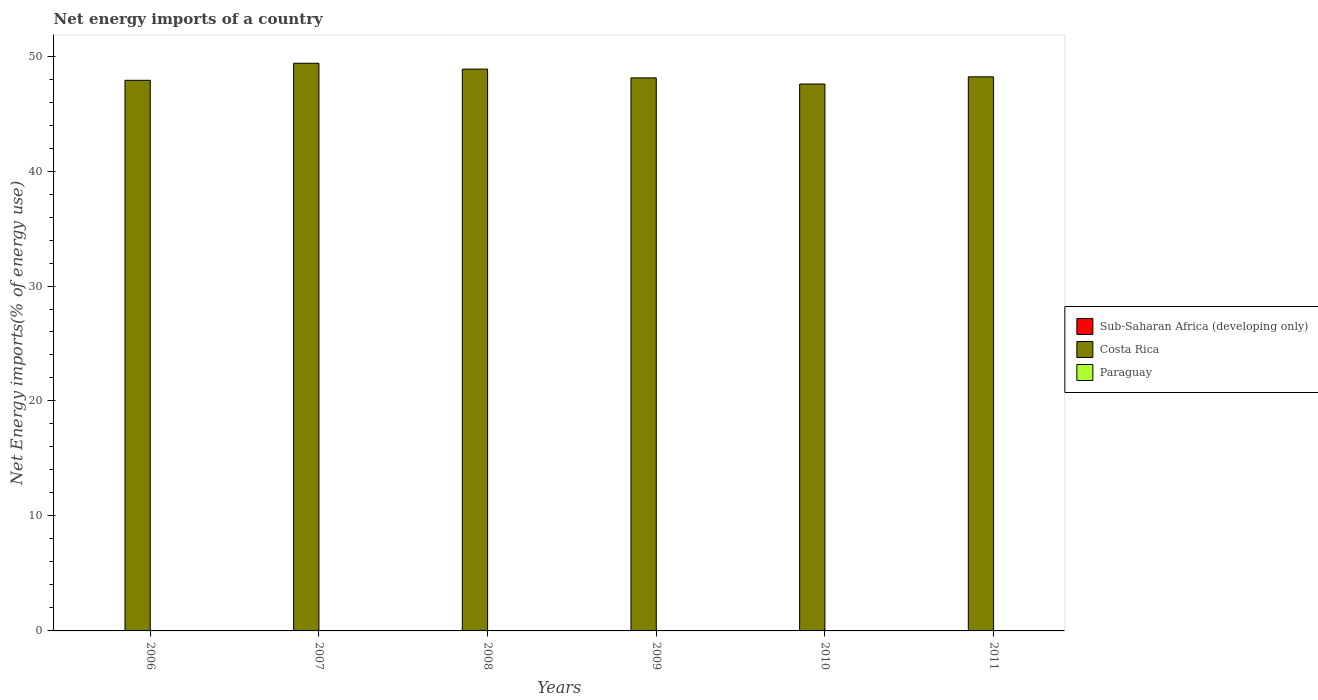How many different coloured bars are there?
Ensure brevity in your answer.  1. How many bars are there on the 1st tick from the left?
Your answer should be very brief. 1. In how many cases, is the number of bars for a given year not equal to the number of legend labels?
Provide a succinct answer. 6. What is the net energy imports in Costa Rica in 2010?
Offer a terse response. 47.57. Across all years, what is the maximum net energy imports in Costa Rica?
Your response must be concise. 49.37. Across all years, what is the minimum net energy imports in Sub-Saharan Africa (developing only)?
Offer a very short reply. 0. What is the total net energy imports in Costa Rica in the graph?
Ensure brevity in your answer.  290. What is the difference between the net energy imports in Costa Rica in 2007 and that in 2010?
Make the answer very short. 1.81. What is the difference between the net energy imports in Sub-Saharan Africa (developing only) in 2008 and the net energy imports in Costa Rica in 2010?
Provide a succinct answer. -47.57. What is the average net energy imports in Costa Rica per year?
Give a very brief answer. 48.33. What is the ratio of the net energy imports in Costa Rica in 2006 to that in 2008?
Your answer should be very brief. 0.98. What is the difference between the highest and the second highest net energy imports in Costa Rica?
Offer a very short reply. 0.51. What is the difference between the highest and the lowest net energy imports in Costa Rica?
Your response must be concise. 1.81. Is it the case that in every year, the sum of the net energy imports in Costa Rica and net energy imports in Sub-Saharan Africa (developing only) is greater than the net energy imports in Paraguay?
Provide a short and direct response. Yes. How many years are there in the graph?
Provide a short and direct response. 6. Does the graph contain any zero values?
Your response must be concise. Yes. How many legend labels are there?
Give a very brief answer. 3. How are the legend labels stacked?
Give a very brief answer. Vertical. What is the title of the graph?
Your answer should be very brief. Net energy imports of a country. Does "North America" appear as one of the legend labels in the graph?
Offer a very short reply. No. What is the label or title of the X-axis?
Your response must be concise. Years. What is the label or title of the Y-axis?
Ensure brevity in your answer.  Net Energy imports(% of energy use). What is the Net Energy imports(% of energy use) in Sub-Saharan Africa (developing only) in 2006?
Offer a very short reply. 0. What is the Net Energy imports(% of energy use) in Costa Rica in 2006?
Offer a very short reply. 47.89. What is the Net Energy imports(% of energy use) in Paraguay in 2006?
Provide a succinct answer. 0. What is the Net Energy imports(% of energy use) of Sub-Saharan Africa (developing only) in 2007?
Your answer should be compact. 0. What is the Net Energy imports(% of energy use) in Costa Rica in 2007?
Give a very brief answer. 49.37. What is the Net Energy imports(% of energy use) in Costa Rica in 2008?
Ensure brevity in your answer.  48.87. What is the Net Energy imports(% of energy use) of Paraguay in 2008?
Ensure brevity in your answer.  0. What is the Net Energy imports(% of energy use) of Sub-Saharan Africa (developing only) in 2009?
Offer a very short reply. 0. What is the Net Energy imports(% of energy use) in Costa Rica in 2009?
Your answer should be compact. 48.1. What is the Net Energy imports(% of energy use) of Paraguay in 2009?
Offer a terse response. 0. What is the Net Energy imports(% of energy use) of Sub-Saharan Africa (developing only) in 2010?
Offer a terse response. 0. What is the Net Energy imports(% of energy use) of Costa Rica in 2010?
Your answer should be very brief. 47.57. What is the Net Energy imports(% of energy use) in Paraguay in 2010?
Ensure brevity in your answer.  0. What is the Net Energy imports(% of energy use) of Costa Rica in 2011?
Provide a short and direct response. 48.2. What is the Net Energy imports(% of energy use) in Paraguay in 2011?
Provide a succinct answer. 0. Across all years, what is the maximum Net Energy imports(% of energy use) in Costa Rica?
Offer a terse response. 49.37. Across all years, what is the minimum Net Energy imports(% of energy use) in Costa Rica?
Give a very brief answer. 47.57. What is the total Net Energy imports(% of energy use) in Sub-Saharan Africa (developing only) in the graph?
Make the answer very short. 0. What is the total Net Energy imports(% of energy use) in Costa Rica in the graph?
Give a very brief answer. 290. What is the difference between the Net Energy imports(% of energy use) of Costa Rica in 2006 and that in 2007?
Your answer should be compact. -1.48. What is the difference between the Net Energy imports(% of energy use) in Costa Rica in 2006 and that in 2008?
Your response must be concise. -0.97. What is the difference between the Net Energy imports(% of energy use) of Costa Rica in 2006 and that in 2009?
Offer a very short reply. -0.21. What is the difference between the Net Energy imports(% of energy use) in Costa Rica in 2006 and that in 2010?
Provide a short and direct response. 0.32. What is the difference between the Net Energy imports(% of energy use) of Costa Rica in 2006 and that in 2011?
Offer a very short reply. -0.3. What is the difference between the Net Energy imports(% of energy use) of Costa Rica in 2007 and that in 2008?
Your answer should be very brief. 0.51. What is the difference between the Net Energy imports(% of energy use) in Costa Rica in 2007 and that in 2009?
Offer a very short reply. 1.27. What is the difference between the Net Energy imports(% of energy use) in Costa Rica in 2007 and that in 2010?
Your answer should be very brief. 1.81. What is the difference between the Net Energy imports(% of energy use) in Costa Rica in 2007 and that in 2011?
Provide a succinct answer. 1.18. What is the difference between the Net Energy imports(% of energy use) of Costa Rica in 2008 and that in 2009?
Make the answer very short. 0.76. What is the difference between the Net Energy imports(% of energy use) of Costa Rica in 2008 and that in 2010?
Offer a terse response. 1.3. What is the difference between the Net Energy imports(% of energy use) of Costa Rica in 2008 and that in 2011?
Offer a terse response. 0.67. What is the difference between the Net Energy imports(% of energy use) in Costa Rica in 2009 and that in 2010?
Your answer should be compact. 0.53. What is the difference between the Net Energy imports(% of energy use) in Costa Rica in 2009 and that in 2011?
Offer a very short reply. -0.09. What is the difference between the Net Energy imports(% of energy use) in Costa Rica in 2010 and that in 2011?
Your response must be concise. -0.63. What is the average Net Energy imports(% of energy use) of Costa Rica per year?
Make the answer very short. 48.33. What is the average Net Energy imports(% of energy use) of Paraguay per year?
Your answer should be compact. 0. What is the ratio of the Net Energy imports(% of energy use) of Costa Rica in 2006 to that in 2007?
Give a very brief answer. 0.97. What is the ratio of the Net Energy imports(% of energy use) in Costa Rica in 2006 to that in 2008?
Your answer should be compact. 0.98. What is the ratio of the Net Energy imports(% of energy use) in Costa Rica in 2006 to that in 2009?
Keep it short and to the point. 1. What is the ratio of the Net Energy imports(% of energy use) of Costa Rica in 2006 to that in 2010?
Your response must be concise. 1.01. What is the ratio of the Net Energy imports(% of energy use) in Costa Rica in 2007 to that in 2008?
Provide a short and direct response. 1.01. What is the ratio of the Net Energy imports(% of energy use) in Costa Rica in 2007 to that in 2009?
Provide a succinct answer. 1.03. What is the ratio of the Net Energy imports(% of energy use) of Costa Rica in 2007 to that in 2010?
Offer a very short reply. 1.04. What is the ratio of the Net Energy imports(% of energy use) of Costa Rica in 2007 to that in 2011?
Your answer should be very brief. 1.02. What is the ratio of the Net Energy imports(% of energy use) in Costa Rica in 2008 to that in 2009?
Provide a short and direct response. 1.02. What is the ratio of the Net Energy imports(% of energy use) in Costa Rica in 2008 to that in 2010?
Your response must be concise. 1.03. What is the ratio of the Net Energy imports(% of energy use) of Costa Rica in 2008 to that in 2011?
Ensure brevity in your answer.  1.01. What is the ratio of the Net Energy imports(% of energy use) of Costa Rica in 2009 to that in 2010?
Offer a terse response. 1.01. What is the ratio of the Net Energy imports(% of energy use) of Costa Rica in 2009 to that in 2011?
Your response must be concise. 1. What is the ratio of the Net Energy imports(% of energy use) of Costa Rica in 2010 to that in 2011?
Offer a terse response. 0.99. What is the difference between the highest and the second highest Net Energy imports(% of energy use) of Costa Rica?
Make the answer very short. 0.51. What is the difference between the highest and the lowest Net Energy imports(% of energy use) of Costa Rica?
Your response must be concise. 1.81. 